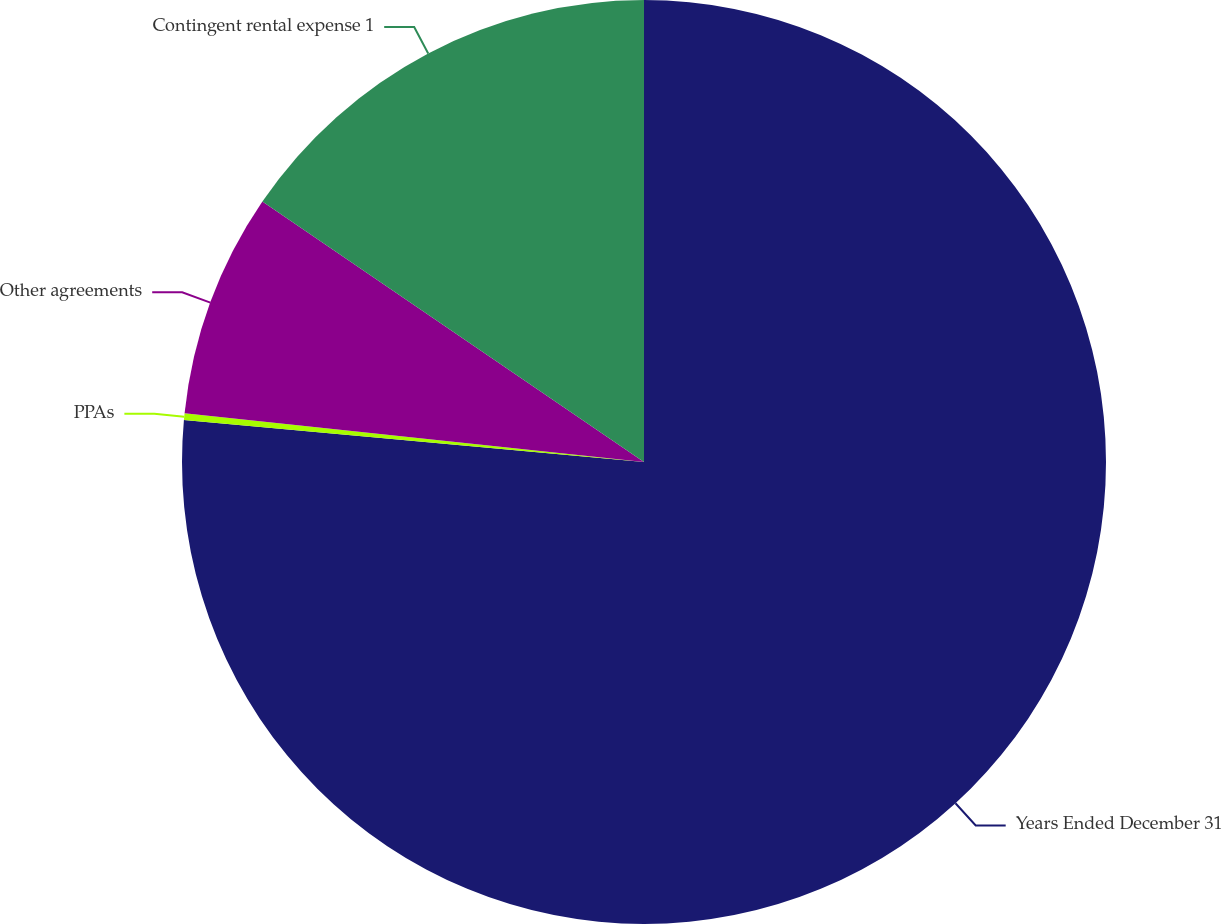Convert chart to OTSL. <chart><loc_0><loc_0><loc_500><loc_500><pie_chart><fcel>Years Ended December 31<fcel>PPAs<fcel>Other agreements<fcel>Contingent rental expense 1<nl><fcel>76.45%<fcel>0.23%<fcel>7.85%<fcel>15.47%<nl></chart> 